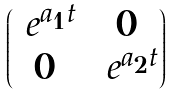<formula> <loc_0><loc_0><loc_500><loc_500>\begin{pmatrix} \ e ^ { a _ { 1 } t } & 0 \\ 0 & \ e ^ { a _ { 2 } t } \end{pmatrix}</formula> 